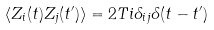<formula> <loc_0><loc_0><loc_500><loc_500>\langle Z _ { i } ( t ) Z _ { j } ( t ^ { \prime } ) \rangle = 2 T i \delta _ { i j } \delta ( t - t ^ { \prime } )</formula> 